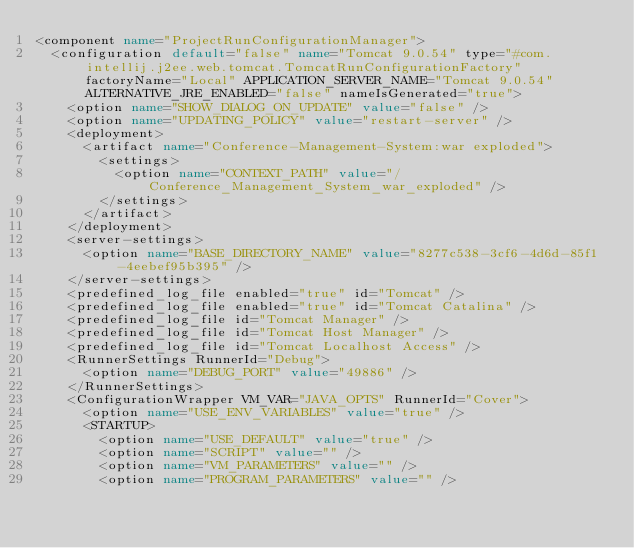Convert code to text. <code><loc_0><loc_0><loc_500><loc_500><_XML_><component name="ProjectRunConfigurationManager">
  <configuration default="false" name="Tomcat 9.0.54" type="#com.intellij.j2ee.web.tomcat.TomcatRunConfigurationFactory" factoryName="Local" APPLICATION_SERVER_NAME="Tomcat 9.0.54" ALTERNATIVE_JRE_ENABLED="false" nameIsGenerated="true">
    <option name="SHOW_DIALOG_ON_UPDATE" value="false" />
    <option name="UPDATING_POLICY" value="restart-server" />
    <deployment>
      <artifact name="Conference-Management-System:war exploded">
        <settings>
          <option name="CONTEXT_PATH" value="/Conference_Management_System_war_exploded" />
        </settings>
      </artifact>
    </deployment>
    <server-settings>
      <option name="BASE_DIRECTORY_NAME" value="8277c538-3cf6-4d6d-85f1-4eebef95b395" />
    </server-settings>
    <predefined_log_file enabled="true" id="Tomcat" />
    <predefined_log_file enabled="true" id="Tomcat Catalina" />
    <predefined_log_file id="Tomcat Manager" />
    <predefined_log_file id="Tomcat Host Manager" />
    <predefined_log_file id="Tomcat Localhost Access" />
    <RunnerSettings RunnerId="Debug">
      <option name="DEBUG_PORT" value="49886" />
    </RunnerSettings>
    <ConfigurationWrapper VM_VAR="JAVA_OPTS" RunnerId="Cover">
      <option name="USE_ENV_VARIABLES" value="true" />
      <STARTUP>
        <option name="USE_DEFAULT" value="true" />
        <option name="SCRIPT" value="" />
        <option name="VM_PARAMETERS" value="" />
        <option name="PROGRAM_PARAMETERS" value="" /></code> 